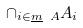Convert formula to latex. <formula><loc_0><loc_0><loc_500><loc_500>\cap _ { i \in \underline { m } \ A } A _ { i }</formula> 